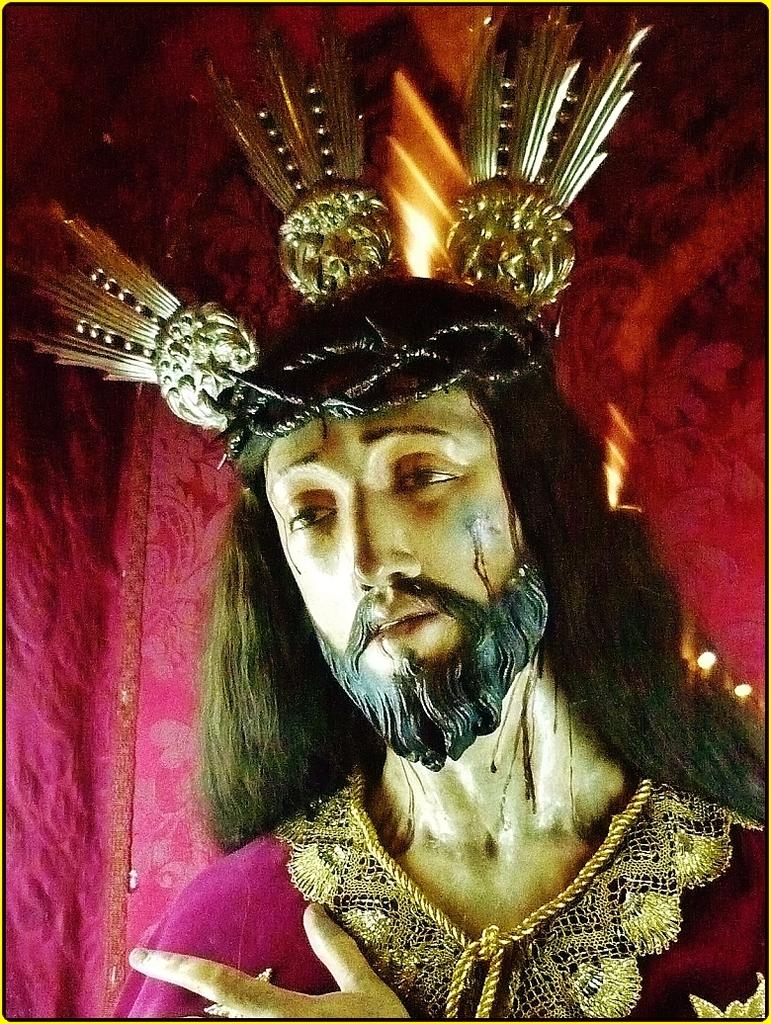What is the main subject in the center of the image? There is a statue in the center of the image. What can be seen in the background of the image? There is cloth and light visible in the background of the image. What type of plants can be seen growing on the statue in the image? There are no plants visible on the statue in the image. 